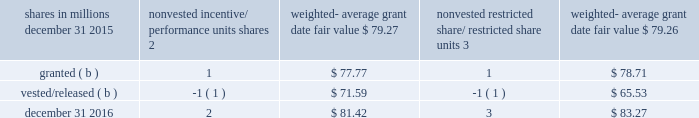At december 31 , 2015 and 2014 , options for 5 million and 6 million shares of common stock were exercisable at a weighted-average price of $ 55.42 and $ 56.21 , respectively .
The total intrinsic value of options exercised was approximately $ .1 billion during 2016 , 2015 and 2014 .
Cash received from option exercises under all incentive plans for 2016 , 2015 and 2014 was approximately $ .1 billion , $ .1 billion and $ .2 billion , respectively .
The tax benefit realized from option exercises under all incentive plans was insignificant for 2016 , 2015 and 2014 .
Shares of common stock available during the next year for the granting of options and other awards under the incentive plans were approximately 39 million shares at december 31 , 2016 .
Total shares of pnc common stock authorized for future issuance under all equity compensation plans totaled approximately 40 million shares at december 31 , 2016 .
During 2016 , we issued approximately 2 million common shares from treasury stock in connection with stock option exercise activity .
As with past exercise activity , we currently intend to utilize primarily treasury stock for any future stock option exercises .
Incentive/performance unit awards and restricted share/restricted share unit awards the fair value of nonvested incentive/performance unit awards and restricted share/restricted share unit awards is initially determined based on prices not less than the market value of our common stock on the date of grant with a reduction for estimated forfeitures .
The value of certain incentive/ performance unit awards is subsequently remeasured based on the achievement of one or more financial and other performance goals .
Additionally , certain incentive/ performance unit awards require subsequent adjustment to their current market value due to certain discretionary risk review triggers .
The weighted-average grant date fair value of incentive/ performance unit awards and restricted share/restricted share unit awards granted in 2016 , 2015 and 2014 was $ 78.37 , $ 91.57 and $ 80.79 per share , respectively .
The total intrinsic value of incentive/performance unit and restricted share/ restricted share unit awards vested during 2016 , 2015 and 2014 was approximately $ .1 billion , $ .2 billion and $ .1 billion , respectively .
We recognize compensation expense for such awards ratably over the corresponding vesting and/or performance periods for each type of program .
Table 78 : nonvested incentive/performance unit awards and restricted share/restricted share unit awards 2013 rollforward ( a ) shares in millions nonvested incentive/ performance units shares weighted- average date fair nonvested restricted share/ restricted weighted- average grant date fair value .
( a ) forfeited awards during 2016 were insignificant .
( b ) includes adjustments for achieving specific performance goals for incentive/ performance unit share awards granted in prior periods .
In table 78 , the units and related weighted-average grant date fair value of the incentive/performance unit share awards exclude the effect of dividends on the underlying shares , as those dividends will be paid in cash if and when the underlying shares are issued to the participants .
Blackrock long-term incentive plans ( ltip ) blackrock adopted the 2002 ltip program to help attract and retain qualified professionals .
At that time , we agreed to transfer up to four million shares of blackrock common stock to fund a portion of the 2002 ltip program and future ltip programs approved by blackrock 2019s board of directors .
In 2009 , our obligation to deliver any remaining blackrock common shares was replaced with an obligation to deliver shares of blackrock 2019s series c preferred stock held by us .
In 2016 , we transferred .5 million shares of blackrock series c preferred stock to blackrock in connection with our obligation .
At december 31 , 2016 , we held approximately .8 million shares of blackrock series c preferred stock which were available to fund our obligations .
See note 23 subsequent events for information on our february 1 , 2017 transfer of .5 million shares of the series c preferred stock to blackrock to satisfy a portion of our ltip obligation .
We account for our blackrock series c preferred stock at fair value , which offsets the impact of marking-to-market the obligation to deliver these shares to blackrock .
See note 6 fair value for additional information regarding the valuation of the blackrock series c preferred stock .
The pnc financial services group , inc .
2013 form 10-k 139 .
What was the total intrinsic value of incentive/performance unit and restricted share/ restricted share unit awards vested during 2016 , 2015 and 2014 in billions? 
Computations: ((.1 + .2) + .1)
Answer: 0.4. At december 31 , 2015 and 2014 , options for 5 million and 6 million shares of common stock were exercisable at a weighted-average price of $ 55.42 and $ 56.21 , respectively .
The total intrinsic value of options exercised was approximately $ .1 billion during 2016 , 2015 and 2014 .
Cash received from option exercises under all incentive plans for 2016 , 2015 and 2014 was approximately $ .1 billion , $ .1 billion and $ .2 billion , respectively .
The tax benefit realized from option exercises under all incentive plans was insignificant for 2016 , 2015 and 2014 .
Shares of common stock available during the next year for the granting of options and other awards under the incentive plans were approximately 39 million shares at december 31 , 2016 .
Total shares of pnc common stock authorized for future issuance under all equity compensation plans totaled approximately 40 million shares at december 31 , 2016 .
During 2016 , we issued approximately 2 million common shares from treasury stock in connection with stock option exercise activity .
As with past exercise activity , we currently intend to utilize primarily treasury stock for any future stock option exercises .
Incentive/performance unit awards and restricted share/restricted share unit awards the fair value of nonvested incentive/performance unit awards and restricted share/restricted share unit awards is initially determined based on prices not less than the market value of our common stock on the date of grant with a reduction for estimated forfeitures .
The value of certain incentive/ performance unit awards is subsequently remeasured based on the achievement of one or more financial and other performance goals .
Additionally , certain incentive/ performance unit awards require subsequent adjustment to their current market value due to certain discretionary risk review triggers .
The weighted-average grant date fair value of incentive/ performance unit awards and restricted share/restricted share unit awards granted in 2016 , 2015 and 2014 was $ 78.37 , $ 91.57 and $ 80.79 per share , respectively .
The total intrinsic value of incentive/performance unit and restricted share/ restricted share unit awards vested during 2016 , 2015 and 2014 was approximately $ .1 billion , $ .2 billion and $ .1 billion , respectively .
We recognize compensation expense for such awards ratably over the corresponding vesting and/or performance periods for each type of program .
Table 78 : nonvested incentive/performance unit awards and restricted share/restricted share unit awards 2013 rollforward ( a ) shares in millions nonvested incentive/ performance units shares weighted- average date fair nonvested restricted share/ restricted weighted- average grant date fair value .
( a ) forfeited awards during 2016 were insignificant .
( b ) includes adjustments for achieving specific performance goals for incentive/ performance unit share awards granted in prior periods .
In table 78 , the units and related weighted-average grant date fair value of the incentive/performance unit share awards exclude the effect of dividends on the underlying shares , as those dividends will be paid in cash if and when the underlying shares are issued to the participants .
Blackrock long-term incentive plans ( ltip ) blackrock adopted the 2002 ltip program to help attract and retain qualified professionals .
At that time , we agreed to transfer up to four million shares of blackrock common stock to fund a portion of the 2002 ltip program and future ltip programs approved by blackrock 2019s board of directors .
In 2009 , our obligation to deliver any remaining blackrock common shares was replaced with an obligation to deliver shares of blackrock 2019s series c preferred stock held by us .
In 2016 , we transferred .5 million shares of blackrock series c preferred stock to blackrock in connection with our obligation .
At december 31 , 2016 , we held approximately .8 million shares of blackrock series c preferred stock which were available to fund our obligations .
See note 23 subsequent events for information on our february 1 , 2017 transfer of .5 million shares of the series c preferred stock to blackrock to satisfy a portion of our ltip obligation .
We account for our blackrock series c preferred stock at fair value , which offsets the impact of marking-to-market the obligation to deliver these shares to blackrock .
See note 6 fair value for additional information regarding the valuation of the blackrock series c preferred stock .
The pnc financial services group , inc .
2013 form 10-k 139 .
Was the total 2016 non-vested incentive/ performance units shares weighted- average grant date fair value greater than the non-vested restricted share/ restricted share units weighted average grant date value? 
Computations: (81.42 > 83.27)
Answer: no. 